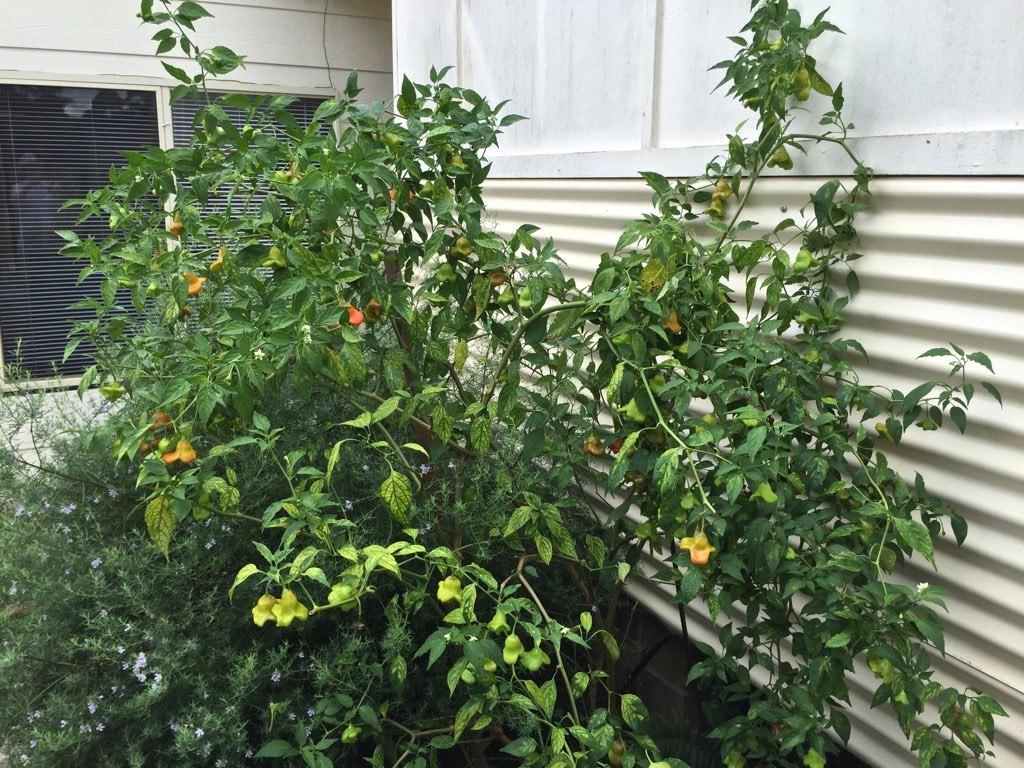What type of plant is visible in the image? There is a plant with flowers in the image. What can be seen in the background of the image? There is a window and a wall in the background of the image. What is located to the right of the image? There is a wall and a metal sheet to the right of the image. Can you see a rabbit wearing a stocking in the image? There is no rabbit or stocking present in the image. 